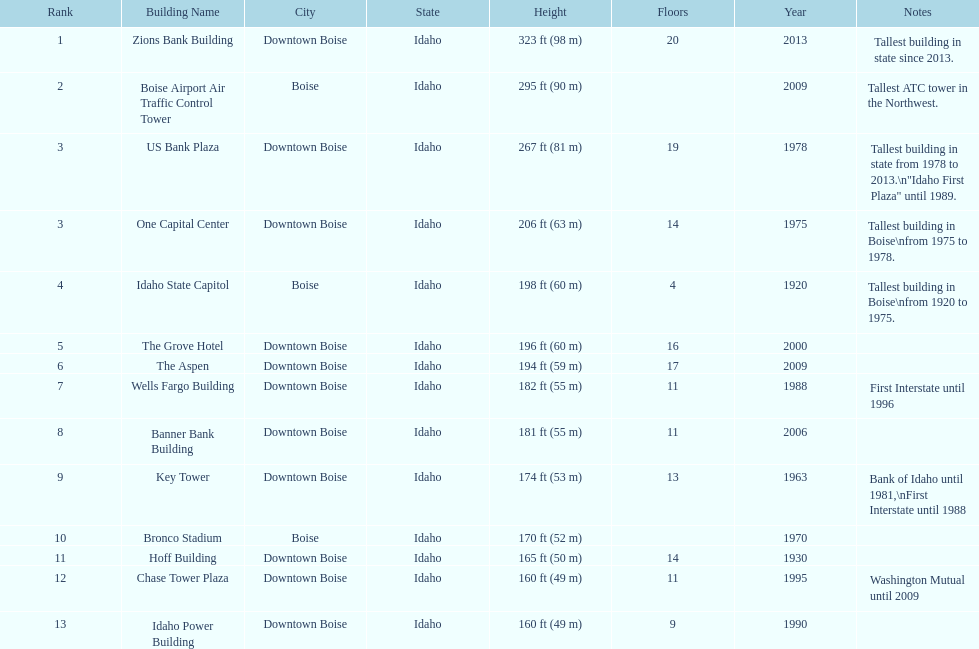Is the bronco stadium above or below 150 ft? Above. 